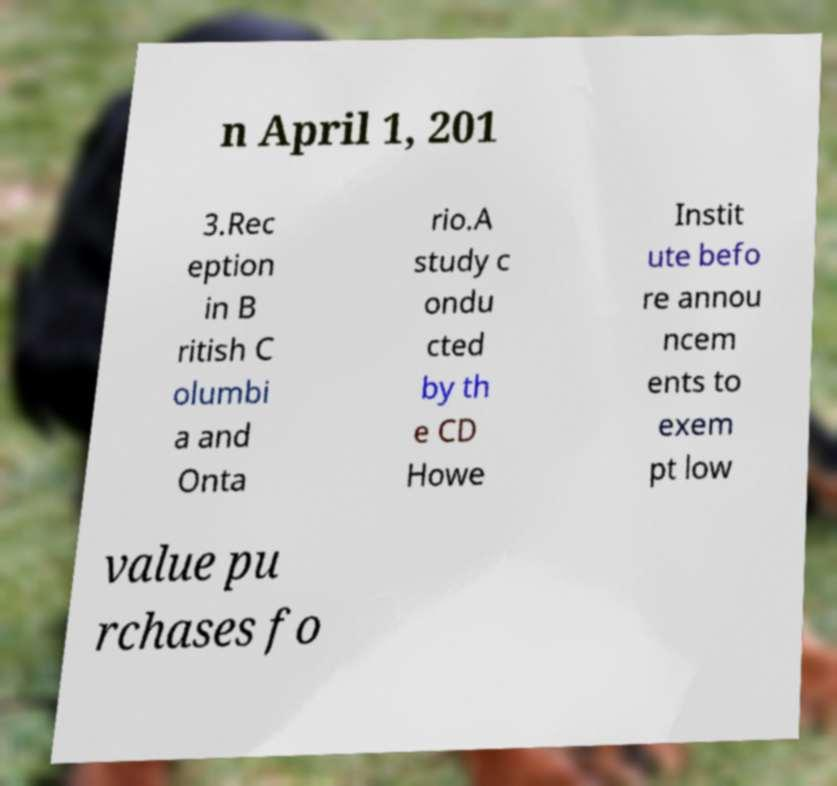What messages or text are displayed in this image? I need them in a readable, typed format. n April 1, 201 3.Rec eption in B ritish C olumbi a and Onta rio.A study c ondu cted by th e CD Howe Instit ute befo re annou ncem ents to exem pt low value pu rchases fo 